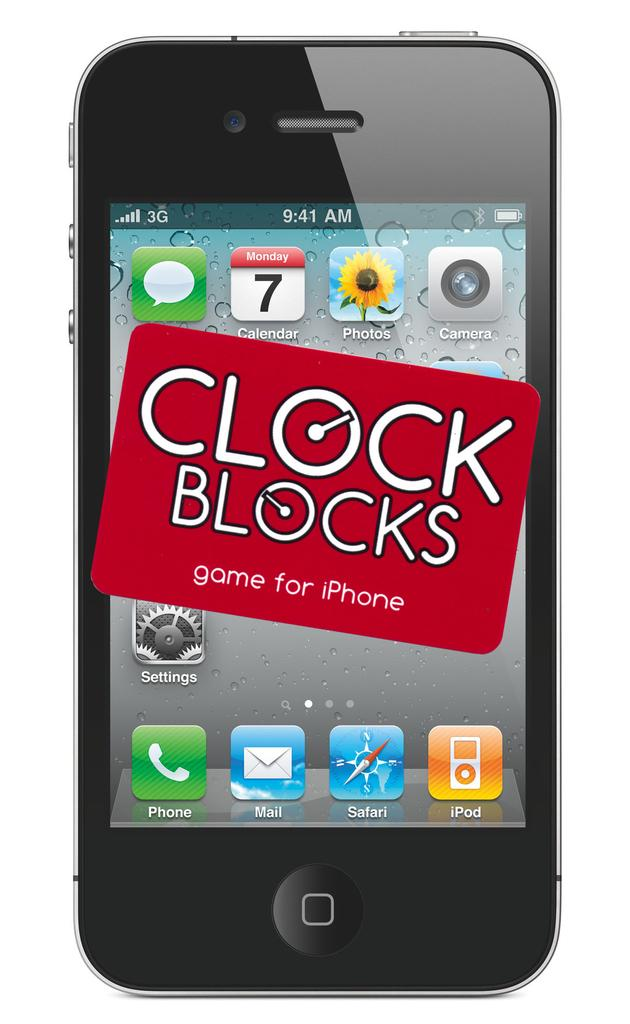Provide a one-sentence caption for the provided image. The iphone has an advertisement for a game called clock blocks. 